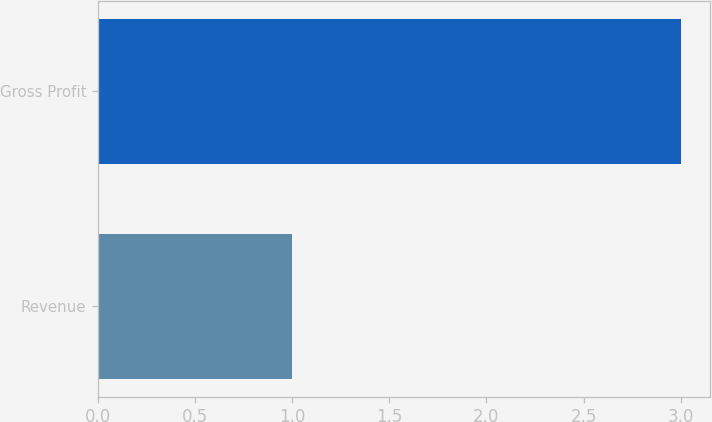Convert chart to OTSL. <chart><loc_0><loc_0><loc_500><loc_500><bar_chart><fcel>Revenue<fcel>Gross Profit<nl><fcel>1<fcel>3<nl></chart> 